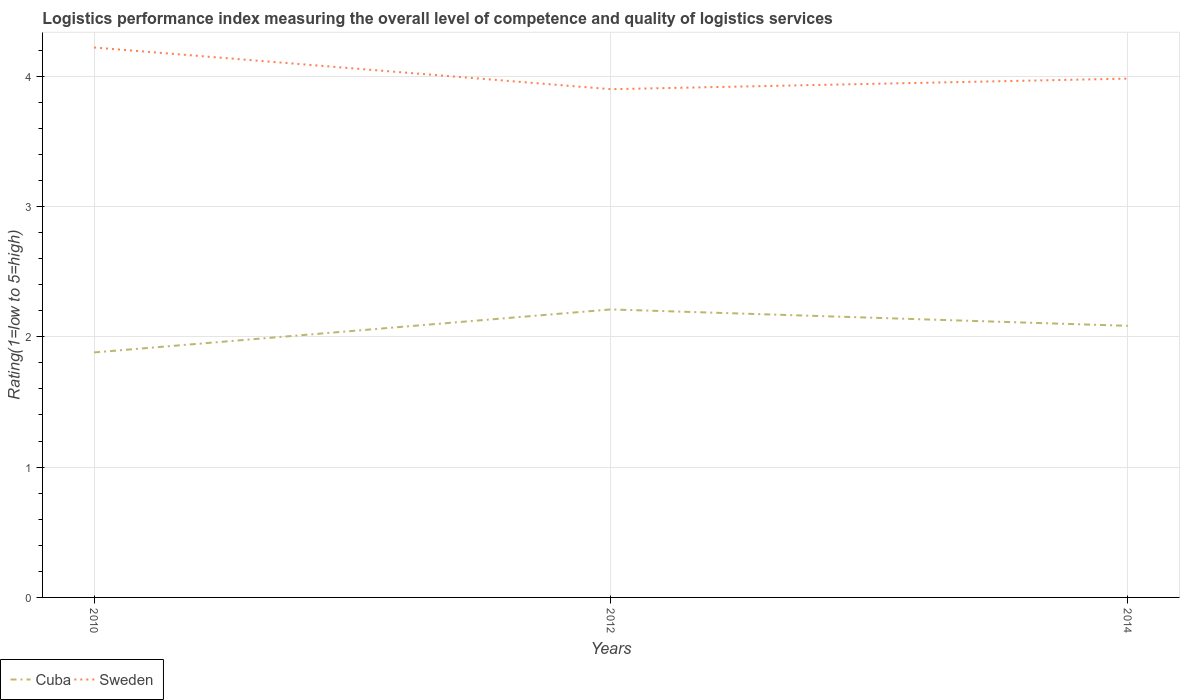Does the line corresponding to Sweden intersect with the line corresponding to Cuba?
Your answer should be compact. No. Is the number of lines equal to the number of legend labels?
Offer a very short reply. Yes. Across all years, what is the maximum Logistic performance index in Cuba?
Provide a short and direct response. 1.88. What is the total Logistic performance index in Sweden in the graph?
Keep it short and to the point. 0.32. What is the difference between the highest and the second highest Logistic performance index in Sweden?
Keep it short and to the point. 0.32. How many lines are there?
Offer a very short reply. 2. How many years are there in the graph?
Your answer should be compact. 3. What is the difference between two consecutive major ticks on the Y-axis?
Your answer should be very brief. 1. Are the values on the major ticks of Y-axis written in scientific E-notation?
Provide a short and direct response. No. Does the graph contain any zero values?
Keep it short and to the point. No. Does the graph contain grids?
Offer a terse response. Yes. Where does the legend appear in the graph?
Offer a very short reply. Bottom left. How are the legend labels stacked?
Make the answer very short. Horizontal. What is the title of the graph?
Provide a succinct answer. Logistics performance index measuring the overall level of competence and quality of logistics services. What is the label or title of the Y-axis?
Give a very brief answer. Rating(1=low to 5=high). What is the Rating(1=low to 5=high) of Cuba in 2010?
Ensure brevity in your answer.  1.88. What is the Rating(1=low to 5=high) of Sweden in 2010?
Ensure brevity in your answer.  4.22. What is the Rating(1=low to 5=high) of Cuba in 2012?
Ensure brevity in your answer.  2.21. What is the Rating(1=low to 5=high) of Cuba in 2014?
Offer a terse response. 2.08. What is the Rating(1=low to 5=high) of Sweden in 2014?
Ensure brevity in your answer.  3.98. Across all years, what is the maximum Rating(1=low to 5=high) in Cuba?
Ensure brevity in your answer.  2.21. Across all years, what is the maximum Rating(1=low to 5=high) of Sweden?
Keep it short and to the point. 4.22. Across all years, what is the minimum Rating(1=low to 5=high) in Cuba?
Your answer should be compact. 1.88. Across all years, what is the minimum Rating(1=low to 5=high) in Sweden?
Provide a short and direct response. 3.9. What is the total Rating(1=low to 5=high) in Cuba in the graph?
Your answer should be very brief. 6.17. What is the total Rating(1=low to 5=high) of Sweden in the graph?
Your answer should be compact. 12.1. What is the difference between the Rating(1=low to 5=high) of Cuba in 2010 and that in 2012?
Your answer should be very brief. -0.33. What is the difference between the Rating(1=low to 5=high) in Sweden in 2010 and that in 2012?
Offer a very short reply. 0.32. What is the difference between the Rating(1=low to 5=high) of Cuba in 2010 and that in 2014?
Offer a terse response. -0.2. What is the difference between the Rating(1=low to 5=high) in Sweden in 2010 and that in 2014?
Offer a terse response. 0.24. What is the difference between the Rating(1=low to 5=high) in Cuba in 2012 and that in 2014?
Your answer should be very brief. 0.13. What is the difference between the Rating(1=low to 5=high) of Sweden in 2012 and that in 2014?
Your response must be concise. -0.08. What is the difference between the Rating(1=low to 5=high) of Cuba in 2010 and the Rating(1=low to 5=high) of Sweden in 2012?
Ensure brevity in your answer.  -2.02. What is the difference between the Rating(1=low to 5=high) in Cuba in 2010 and the Rating(1=low to 5=high) in Sweden in 2014?
Make the answer very short. -2.1. What is the difference between the Rating(1=low to 5=high) in Cuba in 2012 and the Rating(1=low to 5=high) in Sweden in 2014?
Provide a short and direct response. -1.77. What is the average Rating(1=low to 5=high) of Cuba per year?
Your answer should be compact. 2.06. What is the average Rating(1=low to 5=high) of Sweden per year?
Give a very brief answer. 4.03. In the year 2010, what is the difference between the Rating(1=low to 5=high) in Cuba and Rating(1=low to 5=high) in Sweden?
Keep it short and to the point. -2.34. In the year 2012, what is the difference between the Rating(1=low to 5=high) in Cuba and Rating(1=low to 5=high) in Sweden?
Offer a very short reply. -1.69. In the year 2014, what is the difference between the Rating(1=low to 5=high) of Cuba and Rating(1=low to 5=high) of Sweden?
Give a very brief answer. -1.9. What is the ratio of the Rating(1=low to 5=high) of Cuba in 2010 to that in 2012?
Ensure brevity in your answer.  0.85. What is the ratio of the Rating(1=low to 5=high) of Sweden in 2010 to that in 2012?
Give a very brief answer. 1.08. What is the ratio of the Rating(1=low to 5=high) of Cuba in 2010 to that in 2014?
Your answer should be very brief. 0.9. What is the ratio of the Rating(1=low to 5=high) of Sweden in 2010 to that in 2014?
Ensure brevity in your answer.  1.06. What is the ratio of the Rating(1=low to 5=high) of Cuba in 2012 to that in 2014?
Provide a short and direct response. 1.06. What is the ratio of the Rating(1=low to 5=high) in Sweden in 2012 to that in 2014?
Offer a terse response. 0.98. What is the difference between the highest and the second highest Rating(1=low to 5=high) in Cuba?
Keep it short and to the point. 0.13. What is the difference between the highest and the second highest Rating(1=low to 5=high) in Sweden?
Your response must be concise. 0.24. What is the difference between the highest and the lowest Rating(1=low to 5=high) of Cuba?
Your answer should be very brief. 0.33. What is the difference between the highest and the lowest Rating(1=low to 5=high) of Sweden?
Make the answer very short. 0.32. 